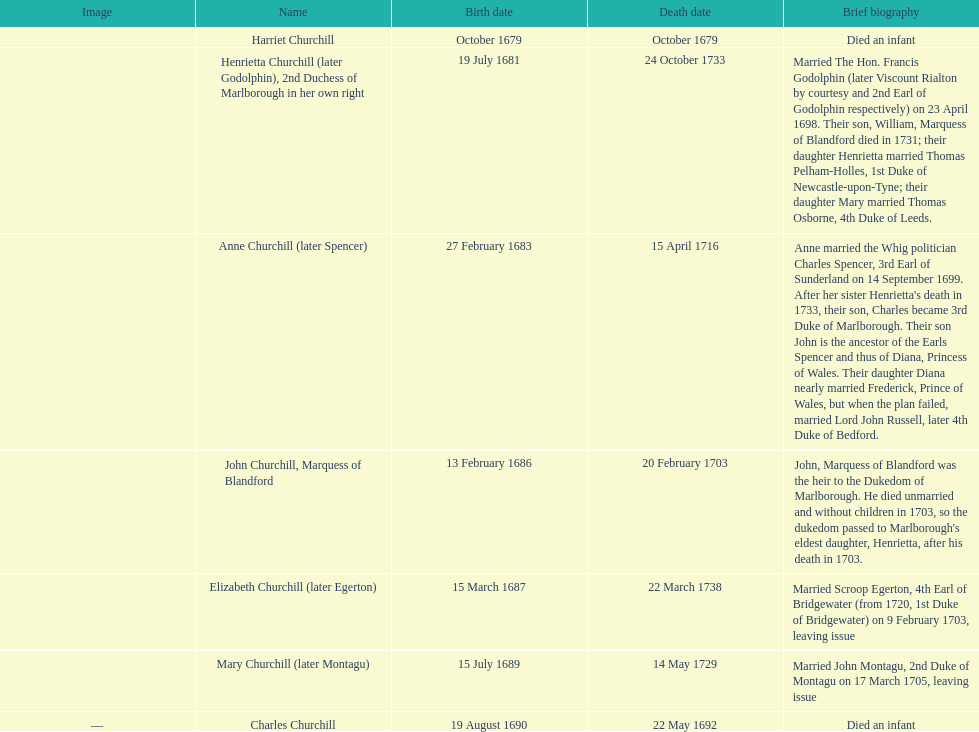Who was born prior to henrietta churchill? Harriet Churchill. Could you help me parse every detail presented in this table? {'header': ['Image', 'Name', 'Birth date', 'Death date', 'Brief biography'], 'rows': [['', 'Harriet Churchill', 'October 1679', 'October 1679', 'Died an infant'], ['', 'Henrietta Churchill (later Godolphin), 2nd Duchess of Marlborough in her own right', '19 July 1681', '24 October 1733', 'Married The Hon. Francis Godolphin (later Viscount Rialton by courtesy and 2nd Earl of Godolphin respectively) on 23 April 1698. Their son, William, Marquess of Blandford died in 1731; their daughter Henrietta married Thomas Pelham-Holles, 1st Duke of Newcastle-upon-Tyne; their daughter Mary married Thomas Osborne, 4th Duke of Leeds.'], ['', 'Anne Churchill (later Spencer)', '27 February 1683', '15 April 1716', "Anne married the Whig politician Charles Spencer, 3rd Earl of Sunderland on 14 September 1699. After her sister Henrietta's death in 1733, their son, Charles became 3rd Duke of Marlborough. Their son John is the ancestor of the Earls Spencer and thus of Diana, Princess of Wales. Their daughter Diana nearly married Frederick, Prince of Wales, but when the plan failed, married Lord John Russell, later 4th Duke of Bedford."], ['', 'John Churchill, Marquess of Blandford', '13 February 1686', '20 February 1703', "John, Marquess of Blandford was the heir to the Dukedom of Marlborough. He died unmarried and without children in 1703, so the dukedom passed to Marlborough's eldest daughter, Henrietta, after his death in 1703."], ['', 'Elizabeth Churchill (later Egerton)', '15 March 1687', '22 March 1738', 'Married Scroop Egerton, 4th Earl of Bridgewater (from 1720, 1st Duke of Bridgewater) on 9 February 1703, leaving issue'], ['', 'Mary Churchill (later Montagu)', '15 July 1689', '14 May 1729', 'Married John Montagu, 2nd Duke of Montagu on 17 March 1705, leaving issue'], ['—', 'Charles Churchill', '19 August 1690', '22 May 1692', 'Died an infant']]} 